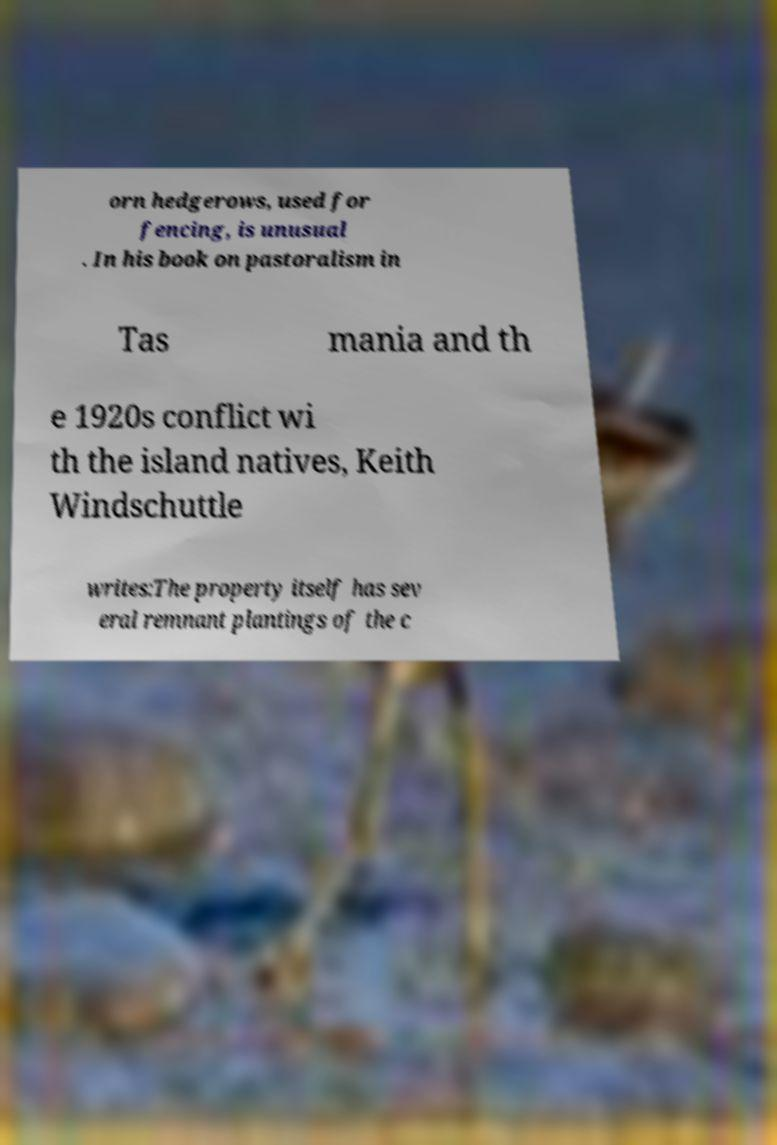Please read and relay the text visible in this image. What does it say? orn hedgerows, used for fencing, is unusual . In his book on pastoralism in Tas mania and th e 1920s conflict wi th the island natives, Keith Windschuttle writes:The property itself has sev eral remnant plantings of the c 